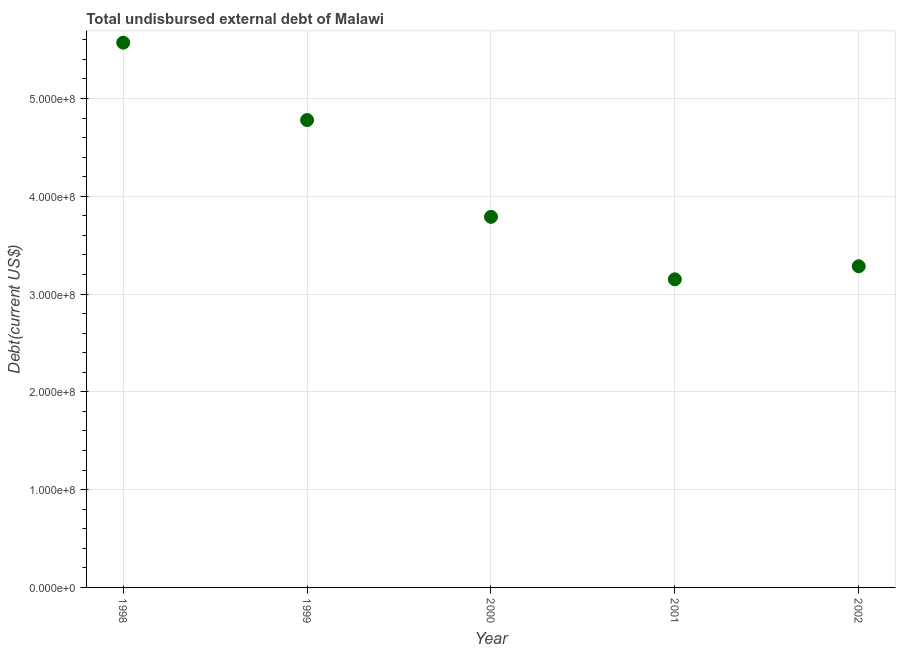What is the total debt in 2000?
Your response must be concise. 3.79e+08. Across all years, what is the maximum total debt?
Make the answer very short. 5.57e+08. Across all years, what is the minimum total debt?
Give a very brief answer. 3.15e+08. In which year was the total debt maximum?
Your response must be concise. 1998. What is the sum of the total debt?
Ensure brevity in your answer.  2.06e+09. What is the difference between the total debt in 1998 and 2001?
Provide a short and direct response. 2.42e+08. What is the average total debt per year?
Give a very brief answer. 4.12e+08. What is the median total debt?
Your answer should be very brief. 3.79e+08. What is the ratio of the total debt in 1998 to that in 2000?
Your answer should be very brief. 1.47. Is the total debt in 1999 less than that in 2000?
Give a very brief answer. No. Is the difference between the total debt in 1998 and 2000 greater than the difference between any two years?
Keep it short and to the point. No. What is the difference between the highest and the second highest total debt?
Your answer should be compact. 7.92e+07. What is the difference between the highest and the lowest total debt?
Make the answer very short. 2.42e+08. In how many years, is the total debt greater than the average total debt taken over all years?
Offer a very short reply. 2. Does the total debt monotonically increase over the years?
Offer a very short reply. No. How many dotlines are there?
Offer a terse response. 1. Are the values on the major ticks of Y-axis written in scientific E-notation?
Provide a succinct answer. Yes. What is the title of the graph?
Keep it short and to the point. Total undisbursed external debt of Malawi. What is the label or title of the X-axis?
Ensure brevity in your answer.  Year. What is the label or title of the Y-axis?
Offer a very short reply. Debt(current US$). What is the Debt(current US$) in 1998?
Your answer should be very brief. 5.57e+08. What is the Debt(current US$) in 1999?
Your answer should be very brief. 4.78e+08. What is the Debt(current US$) in 2000?
Offer a very short reply. 3.79e+08. What is the Debt(current US$) in 2001?
Provide a succinct answer. 3.15e+08. What is the Debt(current US$) in 2002?
Offer a terse response. 3.28e+08. What is the difference between the Debt(current US$) in 1998 and 1999?
Your answer should be very brief. 7.92e+07. What is the difference between the Debt(current US$) in 1998 and 2000?
Your response must be concise. 1.78e+08. What is the difference between the Debt(current US$) in 1998 and 2001?
Your answer should be compact. 2.42e+08. What is the difference between the Debt(current US$) in 1998 and 2002?
Give a very brief answer. 2.29e+08. What is the difference between the Debt(current US$) in 1999 and 2000?
Provide a succinct answer. 9.90e+07. What is the difference between the Debt(current US$) in 1999 and 2001?
Keep it short and to the point. 1.63e+08. What is the difference between the Debt(current US$) in 1999 and 2002?
Offer a terse response. 1.50e+08. What is the difference between the Debt(current US$) in 2000 and 2001?
Keep it short and to the point. 6.39e+07. What is the difference between the Debt(current US$) in 2000 and 2002?
Provide a short and direct response. 5.05e+07. What is the difference between the Debt(current US$) in 2001 and 2002?
Keep it short and to the point. -1.34e+07. What is the ratio of the Debt(current US$) in 1998 to that in 1999?
Your answer should be compact. 1.17. What is the ratio of the Debt(current US$) in 1998 to that in 2000?
Give a very brief answer. 1.47. What is the ratio of the Debt(current US$) in 1998 to that in 2001?
Give a very brief answer. 1.77. What is the ratio of the Debt(current US$) in 1998 to that in 2002?
Provide a short and direct response. 1.7. What is the ratio of the Debt(current US$) in 1999 to that in 2000?
Your answer should be compact. 1.26. What is the ratio of the Debt(current US$) in 1999 to that in 2001?
Your response must be concise. 1.52. What is the ratio of the Debt(current US$) in 1999 to that in 2002?
Keep it short and to the point. 1.46. What is the ratio of the Debt(current US$) in 2000 to that in 2001?
Your answer should be very brief. 1.2. What is the ratio of the Debt(current US$) in 2000 to that in 2002?
Keep it short and to the point. 1.15. 